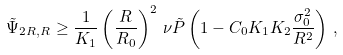<formula> <loc_0><loc_0><loc_500><loc_500>\tilde { \Psi } _ { 2 R , R } \geq \frac { 1 } { K _ { 1 } } \left ( \frac { R } { R _ { 0 } } \right ) ^ { 2 } \, \nu \tilde { P } \left ( 1 - C _ { 0 } K _ { 1 } K _ { 2 } \frac { \sigma _ { 0 } ^ { 2 } } { R ^ { 2 } } \right ) \, ,</formula> 